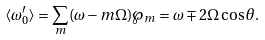<formula> <loc_0><loc_0><loc_500><loc_500>\langle \omega ^ { \prime } _ { 0 } \rangle = \sum _ { m } ( \omega - m \Omega ) \wp _ { m } = \omega \mp 2 \Omega \cos \theta .</formula> 